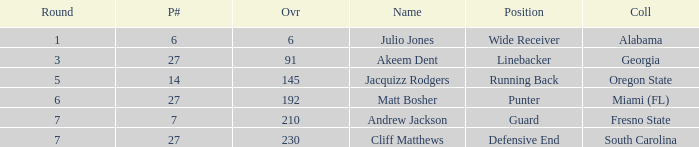Which highest pick number had Akeem Dent as a name and where the overall was less than 91? None. 